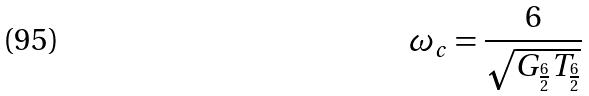<formula> <loc_0><loc_0><loc_500><loc_500>\omega _ { c } = \frac { 6 } { \sqrt { G _ { \frac { 6 } { 2 } } T _ { \frac { 6 } { 2 } } } }</formula> 